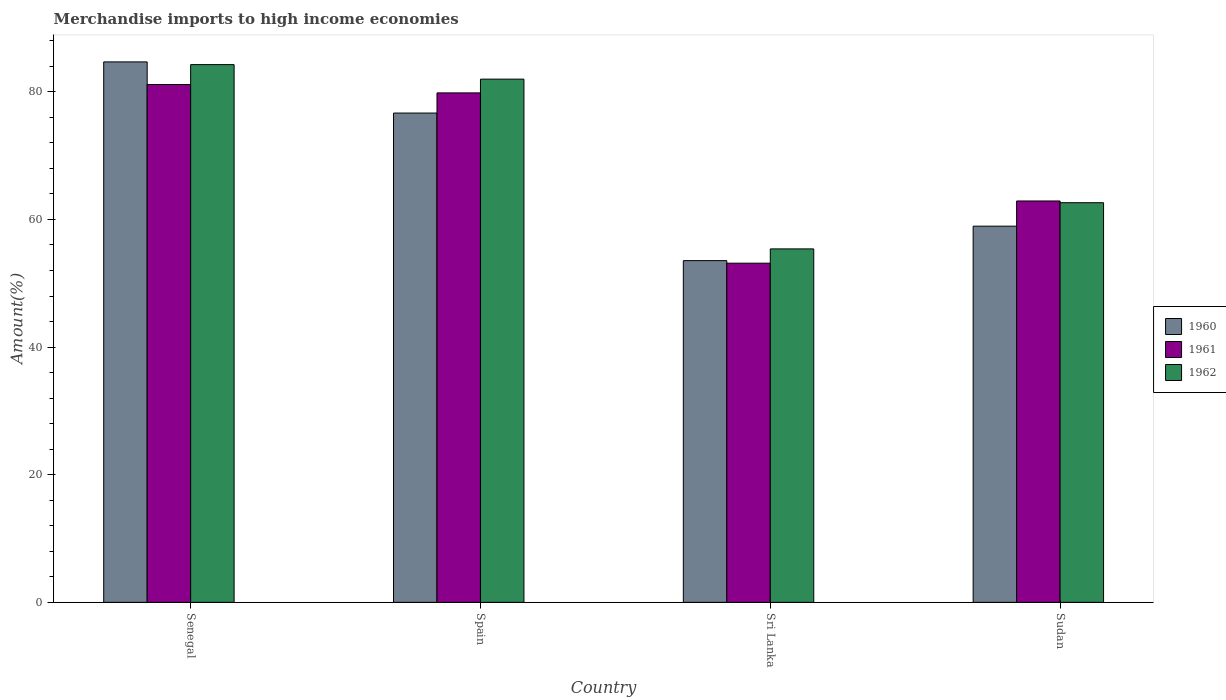How many groups of bars are there?
Ensure brevity in your answer.  4. Are the number of bars on each tick of the X-axis equal?
Offer a terse response. Yes. How many bars are there on the 1st tick from the right?
Make the answer very short. 3. What is the label of the 3rd group of bars from the left?
Ensure brevity in your answer.  Sri Lanka. In how many cases, is the number of bars for a given country not equal to the number of legend labels?
Give a very brief answer. 0. What is the percentage of amount earned from merchandise imports in 1962 in Sudan?
Your answer should be compact. 62.62. Across all countries, what is the maximum percentage of amount earned from merchandise imports in 1962?
Your answer should be very brief. 84.26. Across all countries, what is the minimum percentage of amount earned from merchandise imports in 1962?
Offer a terse response. 55.39. In which country was the percentage of amount earned from merchandise imports in 1960 maximum?
Provide a short and direct response. Senegal. In which country was the percentage of amount earned from merchandise imports in 1961 minimum?
Keep it short and to the point. Sri Lanka. What is the total percentage of amount earned from merchandise imports in 1961 in the graph?
Keep it short and to the point. 277.02. What is the difference between the percentage of amount earned from merchandise imports in 1962 in Senegal and that in Spain?
Your response must be concise. 2.27. What is the difference between the percentage of amount earned from merchandise imports in 1962 in Senegal and the percentage of amount earned from merchandise imports in 1961 in Spain?
Ensure brevity in your answer.  4.43. What is the average percentage of amount earned from merchandise imports in 1961 per country?
Provide a succinct answer. 69.25. What is the difference between the percentage of amount earned from merchandise imports of/in 1960 and percentage of amount earned from merchandise imports of/in 1962 in Spain?
Provide a succinct answer. -5.32. In how many countries, is the percentage of amount earned from merchandise imports in 1960 greater than 56 %?
Your answer should be compact. 3. What is the ratio of the percentage of amount earned from merchandise imports in 1960 in Senegal to that in Spain?
Your answer should be very brief. 1.1. What is the difference between the highest and the second highest percentage of amount earned from merchandise imports in 1962?
Offer a terse response. -2.27. What is the difference between the highest and the lowest percentage of amount earned from merchandise imports in 1961?
Offer a very short reply. 28. In how many countries, is the percentage of amount earned from merchandise imports in 1961 greater than the average percentage of amount earned from merchandise imports in 1961 taken over all countries?
Ensure brevity in your answer.  2. What does the 3rd bar from the right in Spain represents?
Give a very brief answer. 1960. Is it the case that in every country, the sum of the percentage of amount earned from merchandise imports in 1960 and percentage of amount earned from merchandise imports in 1961 is greater than the percentage of amount earned from merchandise imports in 1962?
Your answer should be very brief. Yes. How many bars are there?
Ensure brevity in your answer.  12. How many countries are there in the graph?
Make the answer very short. 4. Does the graph contain any zero values?
Ensure brevity in your answer.  No. What is the title of the graph?
Offer a very short reply. Merchandise imports to high income economies. Does "1992" appear as one of the legend labels in the graph?
Give a very brief answer. No. What is the label or title of the X-axis?
Give a very brief answer. Country. What is the label or title of the Y-axis?
Provide a short and direct response. Amount(%). What is the Amount(%) of 1960 in Senegal?
Your response must be concise. 84.69. What is the Amount(%) in 1961 in Senegal?
Provide a succinct answer. 81.15. What is the Amount(%) in 1962 in Senegal?
Your answer should be compact. 84.26. What is the Amount(%) of 1960 in Spain?
Offer a very short reply. 76.67. What is the Amount(%) in 1961 in Spain?
Offer a very short reply. 79.83. What is the Amount(%) in 1962 in Spain?
Your answer should be compact. 81.99. What is the Amount(%) in 1960 in Sri Lanka?
Your answer should be very brief. 53.55. What is the Amount(%) in 1961 in Sri Lanka?
Make the answer very short. 53.15. What is the Amount(%) in 1962 in Sri Lanka?
Keep it short and to the point. 55.39. What is the Amount(%) in 1960 in Sudan?
Your answer should be very brief. 58.95. What is the Amount(%) of 1961 in Sudan?
Your answer should be very brief. 62.89. What is the Amount(%) of 1962 in Sudan?
Offer a terse response. 62.62. Across all countries, what is the maximum Amount(%) of 1960?
Ensure brevity in your answer.  84.69. Across all countries, what is the maximum Amount(%) in 1961?
Make the answer very short. 81.15. Across all countries, what is the maximum Amount(%) in 1962?
Your response must be concise. 84.26. Across all countries, what is the minimum Amount(%) in 1960?
Keep it short and to the point. 53.55. Across all countries, what is the minimum Amount(%) of 1961?
Provide a succinct answer. 53.15. Across all countries, what is the minimum Amount(%) of 1962?
Offer a very short reply. 55.39. What is the total Amount(%) in 1960 in the graph?
Ensure brevity in your answer.  273.85. What is the total Amount(%) in 1961 in the graph?
Keep it short and to the point. 277.02. What is the total Amount(%) in 1962 in the graph?
Offer a very short reply. 284.26. What is the difference between the Amount(%) of 1960 in Senegal and that in Spain?
Your answer should be compact. 8.01. What is the difference between the Amount(%) of 1961 in Senegal and that in Spain?
Your answer should be compact. 1.32. What is the difference between the Amount(%) of 1962 in Senegal and that in Spain?
Your answer should be compact. 2.27. What is the difference between the Amount(%) of 1960 in Senegal and that in Sri Lanka?
Your answer should be very brief. 31.14. What is the difference between the Amount(%) of 1961 in Senegal and that in Sri Lanka?
Offer a very short reply. 28. What is the difference between the Amount(%) of 1962 in Senegal and that in Sri Lanka?
Keep it short and to the point. 28.88. What is the difference between the Amount(%) of 1960 in Senegal and that in Sudan?
Provide a succinct answer. 25.74. What is the difference between the Amount(%) of 1961 in Senegal and that in Sudan?
Keep it short and to the point. 18.25. What is the difference between the Amount(%) of 1962 in Senegal and that in Sudan?
Provide a short and direct response. 21.64. What is the difference between the Amount(%) of 1960 in Spain and that in Sri Lanka?
Your answer should be compact. 23.12. What is the difference between the Amount(%) in 1961 in Spain and that in Sri Lanka?
Offer a terse response. 26.68. What is the difference between the Amount(%) of 1962 in Spain and that in Sri Lanka?
Offer a terse response. 26.6. What is the difference between the Amount(%) of 1960 in Spain and that in Sudan?
Your answer should be very brief. 17.72. What is the difference between the Amount(%) of 1961 in Spain and that in Sudan?
Make the answer very short. 16.94. What is the difference between the Amount(%) in 1962 in Spain and that in Sudan?
Your answer should be compact. 19.37. What is the difference between the Amount(%) in 1960 in Sri Lanka and that in Sudan?
Your response must be concise. -5.4. What is the difference between the Amount(%) in 1961 in Sri Lanka and that in Sudan?
Provide a short and direct response. -9.75. What is the difference between the Amount(%) in 1962 in Sri Lanka and that in Sudan?
Your response must be concise. -7.24. What is the difference between the Amount(%) in 1960 in Senegal and the Amount(%) in 1961 in Spain?
Provide a short and direct response. 4.86. What is the difference between the Amount(%) in 1960 in Senegal and the Amount(%) in 1962 in Spain?
Give a very brief answer. 2.7. What is the difference between the Amount(%) in 1961 in Senegal and the Amount(%) in 1962 in Spain?
Offer a terse response. -0.84. What is the difference between the Amount(%) of 1960 in Senegal and the Amount(%) of 1961 in Sri Lanka?
Make the answer very short. 31.54. What is the difference between the Amount(%) of 1960 in Senegal and the Amount(%) of 1962 in Sri Lanka?
Your answer should be compact. 29.3. What is the difference between the Amount(%) of 1961 in Senegal and the Amount(%) of 1962 in Sri Lanka?
Offer a very short reply. 25.76. What is the difference between the Amount(%) of 1960 in Senegal and the Amount(%) of 1961 in Sudan?
Your answer should be compact. 21.79. What is the difference between the Amount(%) in 1960 in Senegal and the Amount(%) in 1962 in Sudan?
Ensure brevity in your answer.  22.06. What is the difference between the Amount(%) of 1961 in Senegal and the Amount(%) of 1962 in Sudan?
Your answer should be very brief. 18.53. What is the difference between the Amount(%) in 1960 in Spain and the Amount(%) in 1961 in Sri Lanka?
Your answer should be compact. 23.52. What is the difference between the Amount(%) of 1960 in Spain and the Amount(%) of 1962 in Sri Lanka?
Provide a succinct answer. 21.29. What is the difference between the Amount(%) in 1961 in Spain and the Amount(%) in 1962 in Sri Lanka?
Offer a very short reply. 24.44. What is the difference between the Amount(%) in 1960 in Spain and the Amount(%) in 1961 in Sudan?
Keep it short and to the point. 13.78. What is the difference between the Amount(%) of 1960 in Spain and the Amount(%) of 1962 in Sudan?
Keep it short and to the point. 14.05. What is the difference between the Amount(%) in 1961 in Spain and the Amount(%) in 1962 in Sudan?
Provide a short and direct response. 17.21. What is the difference between the Amount(%) of 1960 in Sri Lanka and the Amount(%) of 1961 in Sudan?
Keep it short and to the point. -9.35. What is the difference between the Amount(%) in 1960 in Sri Lanka and the Amount(%) in 1962 in Sudan?
Make the answer very short. -9.07. What is the difference between the Amount(%) in 1961 in Sri Lanka and the Amount(%) in 1962 in Sudan?
Make the answer very short. -9.47. What is the average Amount(%) in 1960 per country?
Keep it short and to the point. 68.46. What is the average Amount(%) in 1961 per country?
Provide a short and direct response. 69.25. What is the average Amount(%) in 1962 per country?
Your answer should be very brief. 71.06. What is the difference between the Amount(%) in 1960 and Amount(%) in 1961 in Senegal?
Your answer should be very brief. 3.54. What is the difference between the Amount(%) of 1960 and Amount(%) of 1962 in Senegal?
Make the answer very short. 0.43. What is the difference between the Amount(%) of 1961 and Amount(%) of 1962 in Senegal?
Give a very brief answer. -3.11. What is the difference between the Amount(%) in 1960 and Amount(%) in 1961 in Spain?
Your answer should be compact. -3.16. What is the difference between the Amount(%) of 1960 and Amount(%) of 1962 in Spain?
Make the answer very short. -5.32. What is the difference between the Amount(%) in 1961 and Amount(%) in 1962 in Spain?
Provide a succinct answer. -2.16. What is the difference between the Amount(%) in 1960 and Amount(%) in 1961 in Sri Lanka?
Your answer should be very brief. 0.4. What is the difference between the Amount(%) of 1960 and Amount(%) of 1962 in Sri Lanka?
Give a very brief answer. -1.84. What is the difference between the Amount(%) of 1961 and Amount(%) of 1962 in Sri Lanka?
Make the answer very short. -2.24. What is the difference between the Amount(%) in 1960 and Amount(%) in 1961 in Sudan?
Offer a very short reply. -3.95. What is the difference between the Amount(%) of 1960 and Amount(%) of 1962 in Sudan?
Make the answer very short. -3.67. What is the difference between the Amount(%) of 1961 and Amount(%) of 1962 in Sudan?
Your answer should be very brief. 0.27. What is the ratio of the Amount(%) of 1960 in Senegal to that in Spain?
Provide a succinct answer. 1.1. What is the ratio of the Amount(%) in 1961 in Senegal to that in Spain?
Keep it short and to the point. 1.02. What is the ratio of the Amount(%) of 1962 in Senegal to that in Spain?
Offer a very short reply. 1.03. What is the ratio of the Amount(%) in 1960 in Senegal to that in Sri Lanka?
Give a very brief answer. 1.58. What is the ratio of the Amount(%) in 1961 in Senegal to that in Sri Lanka?
Your answer should be very brief. 1.53. What is the ratio of the Amount(%) of 1962 in Senegal to that in Sri Lanka?
Ensure brevity in your answer.  1.52. What is the ratio of the Amount(%) of 1960 in Senegal to that in Sudan?
Provide a succinct answer. 1.44. What is the ratio of the Amount(%) in 1961 in Senegal to that in Sudan?
Provide a succinct answer. 1.29. What is the ratio of the Amount(%) in 1962 in Senegal to that in Sudan?
Give a very brief answer. 1.35. What is the ratio of the Amount(%) in 1960 in Spain to that in Sri Lanka?
Your response must be concise. 1.43. What is the ratio of the Amount(%) of 1961 in Spain to that in Sri Lanka?
Offer a terse response. 1.5. What is the ratio of the Amount(%) in 1962 in Spain to that in Sri Lanka?
Ensure brevity in your answer.  1.48. What is the ratio of the Amount(%) of 1960 in Spain to that in Sudan?
Your answer should be very brief. 1.3. What is the ratio of the Amount(%) in 1961 in Spain to that in Sudan?
Ensure brevity in your answer.  1.27. What is the ratio of the Amount(%) in 1962 in Spain to that in Sudan?
Keep it short and to the point. 1.31. What is the ratio of the Amount(%) in 1960 in Sri Lanka to that in Sudan?
Offer a very short reply. 0.91. What is the ratio of the Amount(%) of 1961 in Sri Lanka to that in Sudan?
Make the answer very short. 0.84. What is the ratio of the Amount(%) of 1962 in Sri Lanka to that in Sudan?
Your answer should be compact. 0.88. What is the difference between the highest and the second highest Amount(%) in 1960?
Your answer should be very brief. 8.01. What is the difference between the highest and the second highest Amount(%) in 1961?
Give a very brief answer. 1.32. What is the difference between the highest and the second highest Amount(%) of 1962?
Ensure brevity in your answer.  2.27. What is the difference between the highest and the lowest Amount(%) in 1960?
Provide a short and direct response. 31.14. What is the difference between the highest and the lowest Amount(%) in 1961?
Provide a short and direct response. 28. What is the difference between the highest and the lowest Amount(%) in 1962?
Provide a succinct answer. 28.88. 